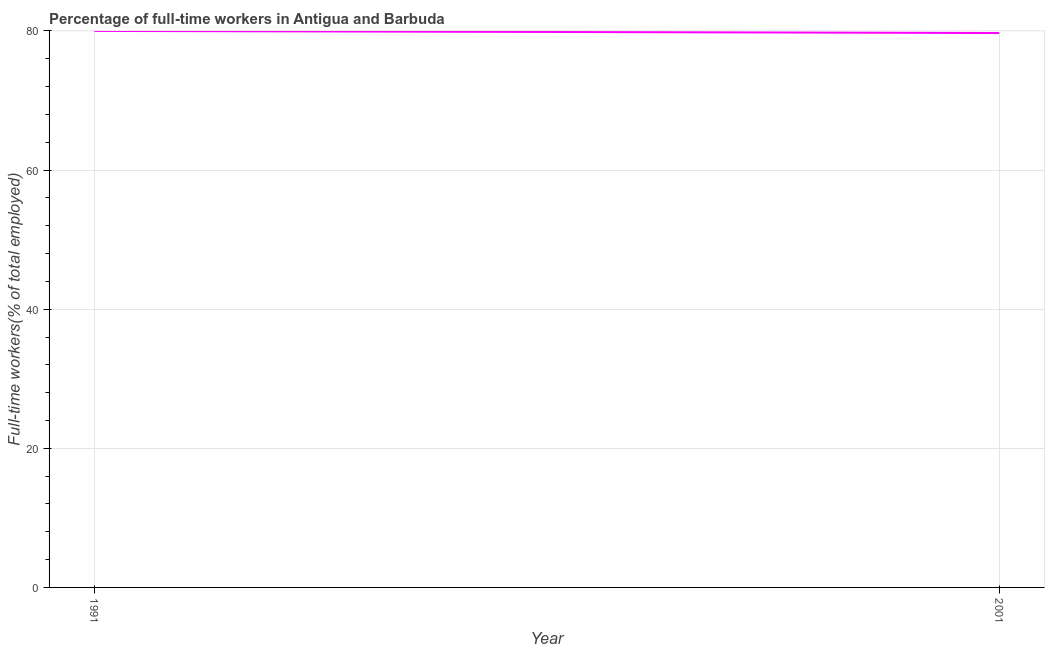What is the percentage of full-time workers in 2001?
Offer a terse response. 79.7. Across all years, what is the maximum percentage of full-time workers?
Your answer should be very brief. 80. Across all years, what is the minimum percentage of full-time workers?
Provide a succinct answer. 79.7. In which year was the percentage of full-time workers maximum?
Your answer should be compact. 1991. In which year was the percentage of full-time workers minimum?
Your answer should be very brief. 2001. What is the sum of the percentage of full-time workers?
Provide a short and direct response. 159.7. What is the difference between the percentage of full-time workers in 1991 and 2001?
Provide a succinct answer. 0.3. What is the average percentage of full-time workers per year?
Your answer should be compact. 79.85. What is the median percentage of full-time workers?
Ensure brevity in your answer.  79.85. Do a majority of the years between 2001 and 1991 (inclusive) have percentage of full-time workers greater than 4 %?
Keep it short and to the point. No. What is the ratio of the percentage of full-time workers in 1991 to that in 2001?
Offer a very short reply. 1. Is the percentage of full-time workers in 1991 less than that in 2001?
Your answer should be compact. No. In how many years, is the percentage of full-time workers greater than the average percentage of full-time workers taken over all years?
Your response must be concise. 1. Does the graph contain any zero values?
Keep it short and to the point. No. What is the title of the graph?
Give a very brief answer. Percentage of full-time workers in Antigua and Barbuda. What is the label or title of the X-axis?
Your answer should be very brief. Year. What is the label or title of the Y-axis?
Provide a short and direct response. Full-time workers(% of total employed). What is the Full-time workers(% of total employed) in 2001?
Your answer should be very brief. 79.7. What is the ratio of the Full-time workers(% of total employed) in 1991 to that in 2001?
Provide a short and direct response. 1. 